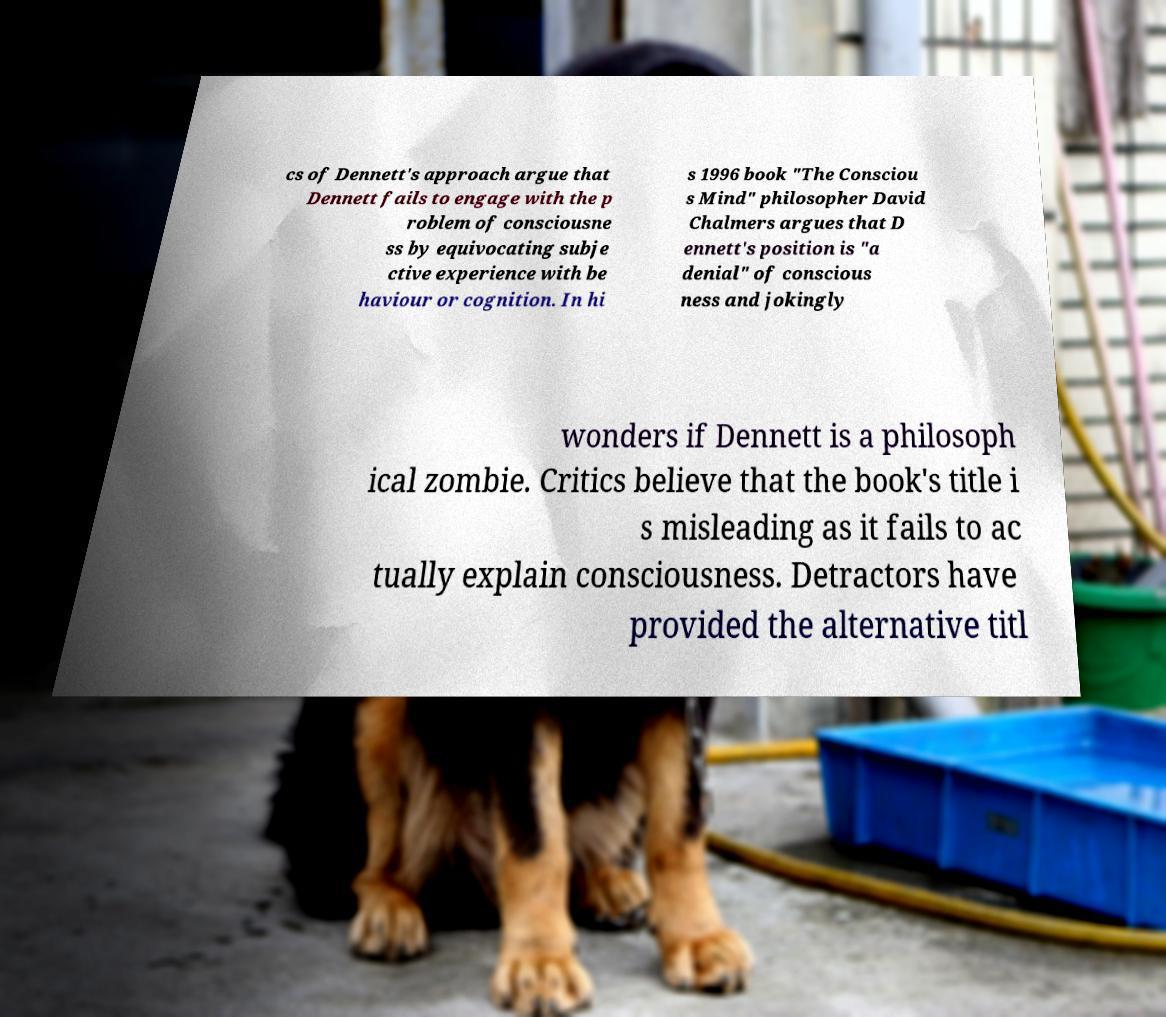Could you extract and type out the text from this image? cs of Dennett's approach argue that Dennett fails to engage with the p roblem of consciousne ss by equivocating subje ctive experience with be haviour or cognition. In hi s 1996 book "The Consciou s Mind" philosopher David Chalmers argues that D ennett's position is "a denial" of conscious ness and jokingly wonders if Dennett is a philosoph ical zombie. Critics believe that the book's title i s misleading as it fails to ac tually explain consciousness. Detractors have provided the alternative titl 